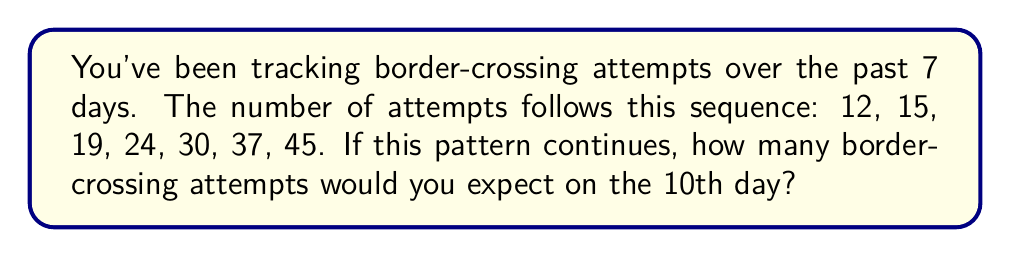Can you solve this math problem? Let's approach this step-by-step:

1) First, let's look at the differences between consecutive terms:
   12 to 15: +3
   15 to 19: +4
   19 to 24: +5
   24 to 30: +6
   30 to 37: +7
   37 to 45: +8

2) We can see that the difference is increasing by 1 each time. This suggests a quadratic sequence.

3) For a quadratic sequence, the second differences should be constant. Let's check:
   3, 4, 5, 6, 7, 8
   1, 1, 1, 1, 1

   Indeed, the second differences are constant (1).

4) The general form of a quadratic sequence is:
   
   $$a_n = \frac{1}{2}d_2n^2 + (d_1 - \frac{1}{2}d_2)n + (a_1 - d_1 + \frac{1}{2}d_2)$$

   Where $d_2$ is the second difference, $d_1$ is the first difference, and $a_1$ is the first term.

5) In our case:
   $d_2 = 1$
   $d_1 = 3$ (the first difference)
   $a_1 = 12$ (the first term)

6) Substituting these values:

   $$a_n = \frac{1}{2}(1)n^2 + (3 - \frac{1}{2})n + (12 - 3 + \frac{1}{2})$$
   
   $$a_n = \frac{1}{2}n^2 + \frac{5}{2}n + \frac{19}{2}$$

7) To find the 10th term, we substitute $n = 10$:

   $$a_{10} = \frac{1}{2}(10)^2 + \frac{5}{2}(10) + \frac{19}{2}$$
   
   $$a_{10} = 50 + 25 + \frac{19}{2} = 75 + \frac{19}{2} = \frac{169}{2}$$

8) Therefore, on the 10th day, we would expect $\frac{169}{2} = 84.5$ border-crossing attempts.

9) Since we're dealing with whole numbers of attempts, we round to the nearest integer: 85.
Answer: 85 